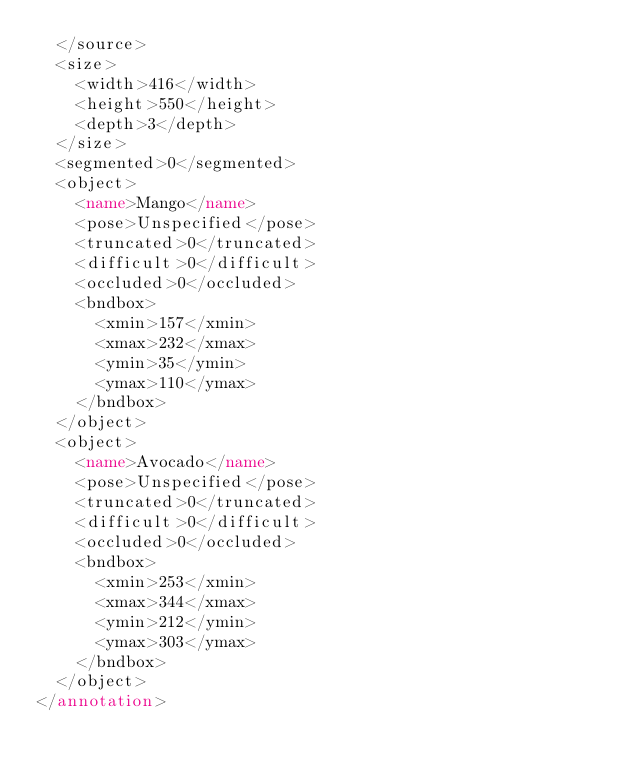<code> <loc_0><loc_0><loc_500><loc_500><_XML_>	</source>
	<size>
		<width>416</width>
		<height>550</height>
		<depth>3</depth>
	</size>
	<segmented>0</segmented>
	<object>
		<name>Mango</name>
		<pose>Unspecified</pose>
		<truncated>0</truncated>
		<difficult>0</difficult>
		<occluded>0</occluded>
		<bndbox>
			<xmin>157</xmin>
			<xmax>232</xmax>
			<ymin>35</ymin>
			<ymax>110</ymax>
		</bndbox>
	</object>
	<object>
		<name>Avocado</name>
		<pose>Unspecified</pose>
		<truncated>0</truncated>
		<difficult>0</difficult>
		<occluded>0</occluded>
		<bndbox>
			<xmin>253</xmin>
			<xmax>344</xmax>
			<ymin>212</ymin>
			<ymax>303</ymax>
		</bndbox>
	</object>
</annotation>
</code> 